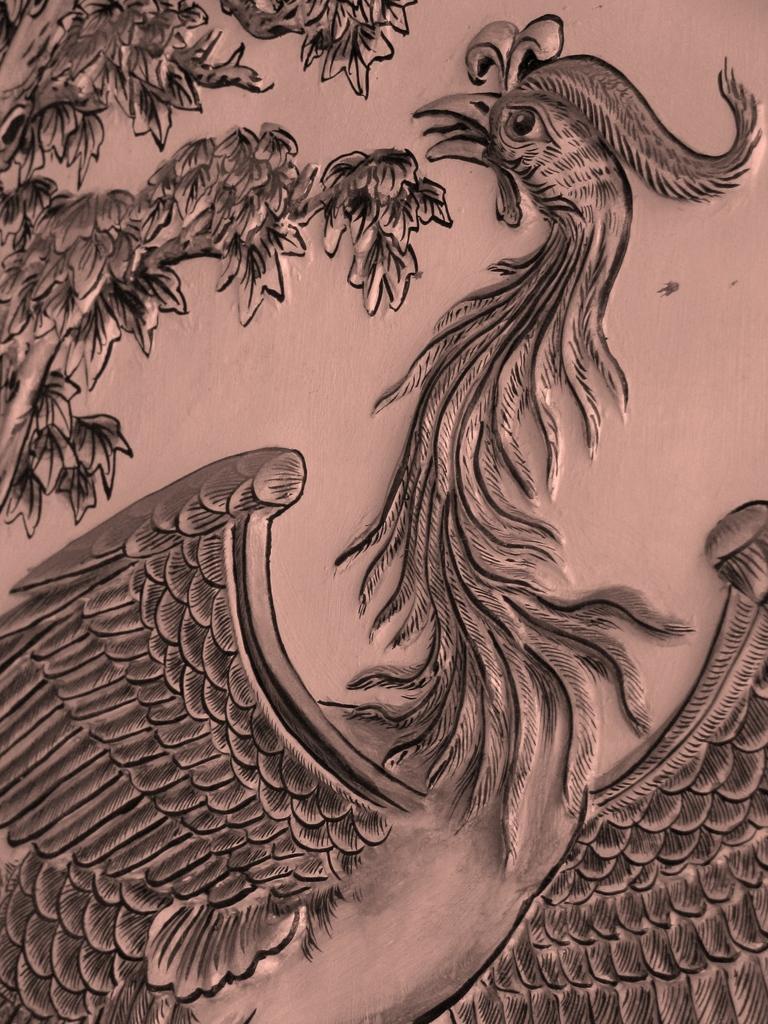How would you summarize this image in a sentence or two? In the center of the image there is a painting. 